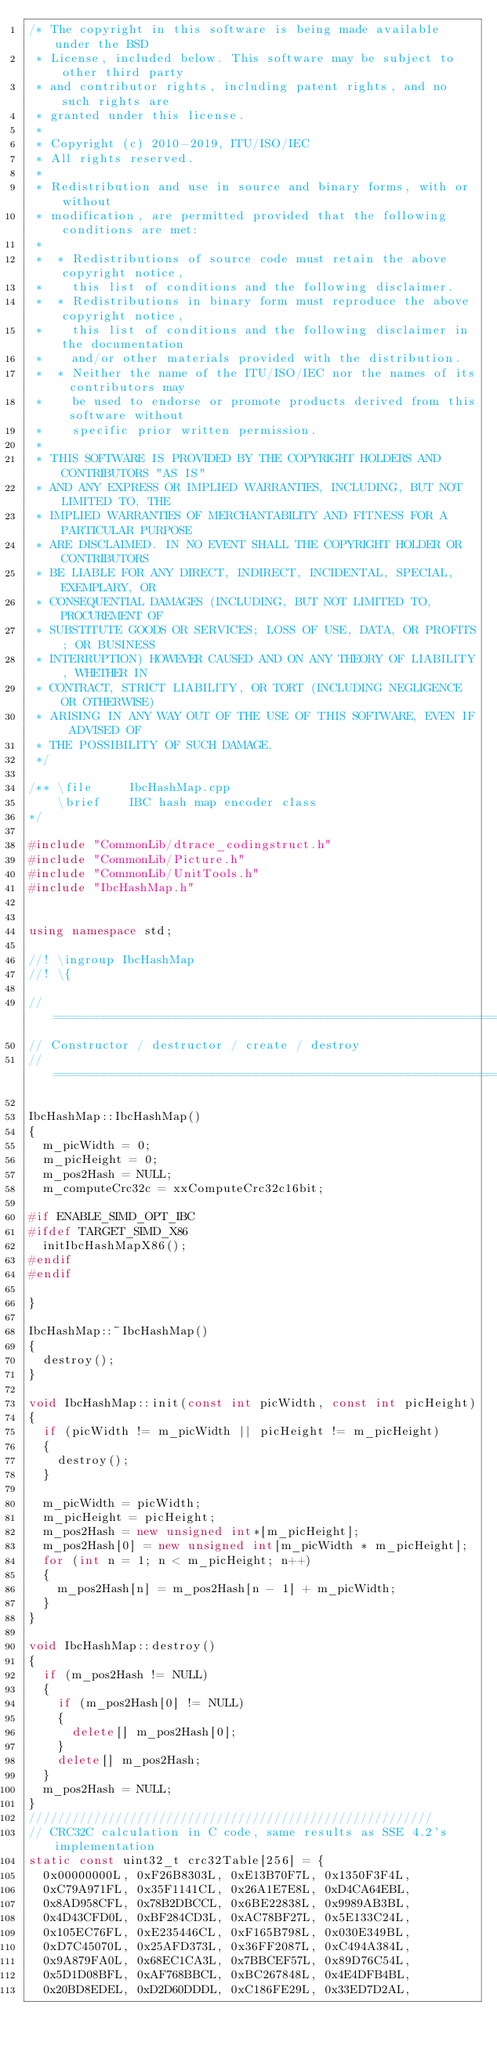Convert code to text. <code><loc_0><loc_0><loc_500><loc_500><_C++_>/* The copyright in this software is being made available under the BSD
 * License, included below. This software may be subject to other third party
 * and contributor rights, including patent rights, and no such rights are
 * granted under this license.
 *
 * Copyright (c) 2010-2019, ITU/ISO/IEC
 * All rights reserved.
 *
 * Redistribution and use in source and binary forms, with or without
 * modification, are permitted provided that the following conditions are met:
 *
 *  * Redistributions of source code must retain the above copyright notice,
 *    this list of conditions and the following disclaimer.
 *  * Redistributions in binary form must reproduce the above copyright notice,
 *    this list of conditions and the following disclaimer in the documentation
 *    and/or other materials provided with the distribution.
 *  * Neither the name of the ITU/ISO/IEC nor the names of its contributors may
 *    be used to endorse or promote products derived from this software without
 *    specific prior written permission.
 *
 * THIS SOFTWARE IS PROVIDED BY THE COPYRIGHT HOLDERS AND CONTRIBUTORS "AS IS"
 * AND ANY EXPRESS OR IMPLIED WARRANTIES, INCLUDING, BUT NOT LIMITED TO, THE
 * IMPLIED WARRANTIES OF MERCHANTABILITY AND FITNESS FOR A PARTICULAR PURPOSE
 * ARE DISCLAIMED. IN NO EVENT SHALL THE COPYRIGHT HOLDER OR CONTRIBUTORS
 * BE LIABLE FOR ANY DIRECT, INDIRECT, INCIDENTAL, SPECIAL, EXEMPLARY, OR
 * CONSEQUENTIAL DAMAGES (INCLUDING, BUT NOT LIMITED TO, PROCUREMENT OF
 * SUBSTITUTE GOODS OR SERVICES; LOSS OF USE, DATA, OR PROFITS; OR BUSINESS
 * INTERRUPTION) HOWEVER CAUSED AND ON ANY THEORY OF LIABILITY, WHETHER IN
 * CONTRACT, STRICT LIABILITY, OR TORT (INCLUDING NEGLIGENCE OR OTHERWISE)
 * ARISING IN ANY WAY OUT OF THE USE OF THIS SOFTWARE, EVEN IF ADVISED OF
 * THE POSSIBILITY OF SUCH DAMAGE.
 */

/** \file     IbcHashMap.cpp
    \brief    IBC hash map encoder class
*/

#include "CommonLib/dtrace_codingstruct.h"
#include "CommonLib/Picture.h"
#include "CommonLib/UnitTools.h"
#include "IbcHashMap.h"


using namespace std;

//! \ingroup IbcHashMap
//! \{

// ====================================================================================================================
// Constructor / destructor / create / destroy
// ====================================================================================================================

IbcHashMap::IbcHashMap()
{
  m_picWidth = 0;
  m_picHeight = 0;
  m_pos2Hash = NULL;
  m_computeCrc32c = xxComputeCrc32c16bit;

#if ENABLE_SIMD_OPT_IBC
#ifdef TARGET_SIMD_X86
  initIbcHashMapX86();
#endif
#endif

}

IbcHashMap::~IbcHashMap()
{
  destroy();
}

void IbcHashMap::init(const int picWidth, const int picHeight)
{
  if (picWidth != m_picWidth || picHeight != m_picHeight)
  {
    destroy();
  }

  m_picWidth = picWidth;
  m_picHeight = picHeight;
  m_pos2Hash = new unsigned int*[m_picHeight];
  m_pos2Hash[0] = new unsigned int[m_picWidth * m_picHeight];
  for (int n = 1; n < m_picHeight; n++)
  {
    m_pos2Hash[n] = m_pos2Hash[n - 1] + m_picWidth;
  }
}

void IbcHashMap::destroy()
{
  if (m_pos2Hash != NULL)
  {
    if (m_pos2Hash[0] != NULL)
    {
      delete[] m_pos2Hash[0];
    }
    delete[] m_pos2Hash;
  }
  m_pos2Hash = NULL;
}
////////////////////////////////////////////////////////
// CRC32C calculation in C code, same results as SSE 4.2's implementation
static const uint32_t crc32Table[256] = {
  0x00000000L, 0xF26B8303L, 0xE13B70F7L, 0x1350F3F4L,
  0xC79A971FL, 0x35F1141CL, 0x26A1E7E8L, 0xD4CA64EBL,
  0x8AD958CFL, 0x78B2DBCCL, 0x6BE22838L, 0x9989AB3BL,
  0x4D43CFD0L, 0xBF284CD3L, 0xAC78BF27L, 0x5E133C24L,
  0x105EC76FL, 0xE235446CL, 0xF165B798L, 0x030E349BL,
  0xD7C45070L, 0x25AFD373L, 0x36FF2087L, 0xC494A384L,
  0x9A879FA0L, 0x68EC1CA3L, 0x7BBCEF57L, 0x89D76C54L,
  0x5D1D08BFL, 0xAF768BBCL, 0xBC267848L, 0x4E4DFB4BL,
  0x20BD8EDEL, 0xD2D60DDDL, 0xC186FE29L, 0x33ED7D2AL,</code> 